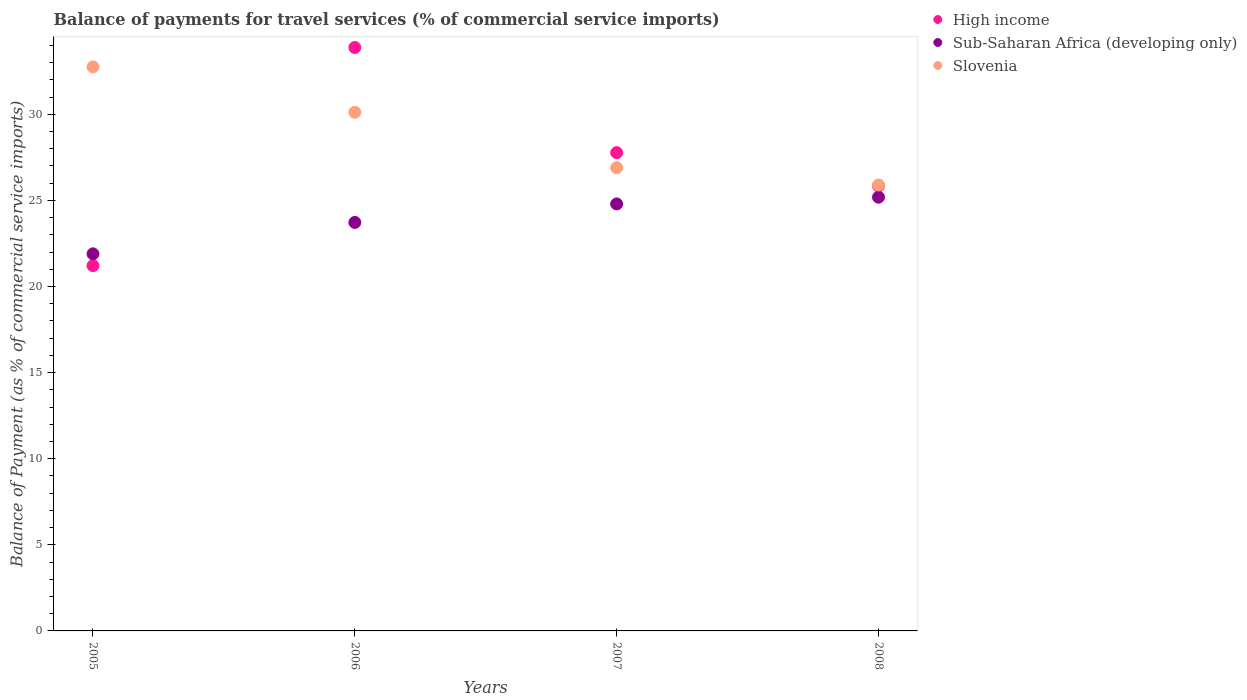How many different coloured dotlines are there?
Offer a very short reply. 3. Is the number of dotlines equal to the number of legend labels?
Make the answer very short. Yes. What is the balance of payments for travel services in Sub-Saharan Africa (developing only) in 2007?
Your response must be concise. 24.79. Across all years, what is the maximum balance of payments for travel services in Slovenia?
Offer a very short reply. 32.75. Across all years, what is the minimum balance of payments for travel services in High income?
Your response must be concise. 21.21. In which year was the balance of payments for travel services in High income maximum?
Give a very brief answer. 2006. In which year was the balance of payments for travel services in High income minimum?
Offer a terse response. 2005. What is the total balance of payments for travel services in High income in the graph?
Offer a very short reply. 108.69. What is the difference between the balance of payments for travel services in Slovenia in 2007 and that in 2008?
Give a very brief answer. 1. What is the difference between the balance of payments for travel services in High income in 2005 and the balance of payments for travel services in Slovenia in 2008?
Ensure brevity in your answer.  -4.68. What is the average balance of payments for travel services in High income per year?
Ensure brevity in your answer.  27.17. In the year 2005, what is the difference between the balance of payments for travel services in Sub-Saharan Africa (developing only) and balance of payments for travel services in High income?
Your answer should be very brief. 0.69. In how many years, is the balance of payments for travel services in Sub-Saharan Africa (developing only) greater than 26 %?
Provide a succinct answer. 0. What is the ratio of the balance of payments for travel services in Sub-Saharan Africa (developing only) in 2007 to that in 2008?
Offer a very short reply. 0.98. Is the balance of payments for travel services in Sub-Saharan Africa (developing only) in 2005 less than that in 2008?
Provide a succinct answer. Yes. What is the difference between the highest and the second highest balance of payments for travel services in Slovenia?
Your answer should be very brief. 2.64. What is the difference between the highest and the lowest balance of payments for travel services in Slovenia?
Provide a short and direct response. 6.86. Is it the case that in every year, the sum of the balance of payments for travel services in High income and balance of payments for travel services in Sub-Saharan Africa (developing only)  is greater than the balance of payments for travel services in Slovenia?
Your response must be concise. Yes. Does the balance of payments for travel services in High income monotonically increase over the years?
Offer a very short reply. No. How many dotlines are there?
Offer a terse response. 3. How many years are there in the graph?
Offer a very short reply. 4. Does the graph contain any zero values?
Your answer should be compact. No. Where does the legend appear in the graph?
Provide a succinct answer. Top right. How many legend labels are there?
Provide a succinct answer. 3. How are the legend labels stacked?
Offer a terse response. Vertical. What is the title of the graph?
Provide a succinct answer. Balance of payments for travel services (% of commercial service imports). What is the label or title of the X-axis?
Ensure brevity in your answer.  Years. What is the label or title of the Y-axis?
Give a very brief answer. Balance of Payment (as % of commercial service imports). What is the Balance of Payment (as % of commercial service imports) in High income in 2005?
Offer a terse response. 21.21. What is the Balance of Payment (as % of commercial service imports) of Sub-Saharan Africa (developing only) in 2005?
Ensure brevity in your answer.  21.89. What is the Balance of Payment (as % of commercial service imports) in Slovenia in 2005?
Keep it short and to the point. 32.75. What is the Balance of Payment (as % of commercial service imports) of High income in 2006?
Give a very brief answer. 33.88. What is the Balance of Payment (as % of commercial service imports) in Sub-Saharan Africa (developing only) in 2006?
Provide a succinct answer. 23.72. What is the Balance of Payment (as % of commercial service imports) in Slovenia in 2006?
Your answer should be compact. 30.11. What is the Balance of Payment (as % of commercial service imports) of High income in 2007?
Offer a very short reply. 27.77. What is the Balance of Payment (as % of commercial service imports) of Sub-Saharan Africa (developing only) in 2007?
Give a very brief answer. 24.79. What is the Balance of Payment (as % of commercial service imports) of Slovenia in 2007?
Your answer should be very brief. 26.9. What is the Balance of Payment (as % of commercial service imports) in High income in 2008?
Your answer should be compact. 25.84. What is the Balance of Payment (as % of commercial service imports) of Sub-Saharan Africa (developing only) in 2008?
Keep it short and to the point. 25.18. What is the Balance of Payment (as % of commercial service imports) in Slovenia in 2008?
Your answer should be very brief. 25.89. Across all years, what is the maximum Balance of Payment (as % of commercial service imports) of High income?
Your response must be concise. 33.88. Across all years, what is the maximum Balance of Payment (as % of commercial service imports) in Sub-Saharan Africa (developing only)?
Offer a terse response. 25.18. Across all years, what is the maximum Balance of Payment (as % of commercial service imports) of Slovenia?
Ensure brevity in your answer.  32.75. Across all years, what is the minimum Balance of Payment (as % of commercial service imports) of High income?
Provide a short and direct response. 21.21. Across all years, what is the minimum Balance of Payment (as % of commercial service imports) in Sub-Saharan Africa (developing only)?
Ensure brevity in your answer.  21.89. Across all years, what is the minimum Balance of Payment (as % of commercial service imports) of Slovenia?
Offer a terse response. 25.89. What is the total Balance of Payment (as % of commercial service imports) in High income in the graph?
Your answer should be compact. 108.69. What is the total Balance of Payment (as % of commercial service imports) in Sub-Saharan Africa (developing only) in the graph?
Offer a very short reply. 95.59. What is the total Balance of Payment (as % of commercial service imports) in Slovenia in the graph?
Ensure brevity in your answer.  115.65. What is the difference between the Balance of Payment (as % of commercial service imports) in High income in 2005 and that in 2006?
Offer a very short reply. -12.67. What is the difference between the Balance of Payment (as % of commercial service imports) in Sub-Saharan Africa (developing only) in 2005 and that in 2006?
Offer a terse response. -1.82. What is the difference between the Balance of Payment (as % of commercial service imports) in Slovenia in 2005 and that in 2006?
Offer a terse response. 2.64. What is the difference between the Balance of Payment (as % of commercial service imports) in High income in 2005 and that in 2007?
Make the answer very short. -6.56. What is the difference between the Balance of Payment (as % of commercial service imports) in Sub-Saharan Africa (developing only) in 2005 and that in 2007?
Your answer should be compact. -2.9. What is the difference between the Balance of Payment (as % of commercial service imports) in Slovenia in 2005 and that in 2007?
Ensure brevity in your answer.  5.86. What is the difference between the Balance of Payment (as % of commercial service imports) in High income in 2005 and that in 2008?
Your answer should be very brief. -4.63. What is the difference between the Balance of Payment (as % of commercial service imports) in Sub-Saharan Africa (developing only) in 2005 and that in 2008?
Offer a terse response. -3.29. What is the difference between the Balance of Payment (as % of commercial service imports) of Slovenia in 2005 and that in 2008?
Offer a very short reply. 6.86. What is the difference between the Balance of Payment (as % of commercial service imports) of High income in 2006 and that in 2007?
Ensure brevity in your answer.  6.11. What is the difference between the Balance of Payment (as % of commercial service imports) in Sub-Saharan Africa (developing only) in 2006 and that in 2007?
Offer a very short reply. -1.07. What is the difference between the Balance of Payment (as % of commercial service imports) of Slovenia in 2006 and that in 2007?
Offer a terse response. 3.22. What is the difference between the Balance of Payment (as % of commercial service imports) of High income in 2006 and that in 2008?
Provide a succinct answer. 8.04. What is the difference between the Balance of Payment (as % of commercial service imports) in Sub-Saharan Africa (developing only) in 2006 and that in 2008?
Give a very brief answer. -1.46. What is the difference between the Balance of Payment (as % of commercial service imports) in Slovenia in 2006 and that in 2008?
Your answer should be very brief. 4.22. What is the difference between the Balance of Payment (as % of commercial service imports) in High income in 2007 and that in 2008?
Your response must be concise. 1.93. What is the difference between the Balance of Payment (as % of commercial service imports) in Sub-Saharan Africa (developing only) in 2007 and that in 2008?
Your answer should be compact. -0.39. What is the difference between the Balance of Payment (as % of commercial service imports) in High income in 2005 and the Balance of Payment (as % of commercial service imports) in Sub-Saharan Africa (developing only) in 2006?
Offer a terse response. -2.51. What is the difference between the Balance of Payment (as % of commercial service imports) of High income in 2005 and the Balance of Payment (as % of commercial service imports) of Slovenia in 2006?
Offer a very short reply. -8.91. What is the difference between the Balance of Payment (as % of commercial service imports) of Sub-Saharan Africa (developing only) in 2005 and the Balance of Payment (as % of commercial service imports) of Slovenia in 2006?
Offer a very short reply. -8.22. What is the difference between the Balance of Payment (as % of commercial service imports) in High income in 2005 and the Balance of Payment (as % of commercial service imports) in Sub-Saharan Africa (developing only) in 2007?
Offer a terse response. -3.58. What is the difference between the Balance of Payment (as % of commercial service imports) of High income in 2005 and the Balance of Payment (as % of commercial service imports) of Slovenia in 2007?
Keep it short and to the point. -5.69. What is the difference between the Balance of Payment (as % of commercial service imports) of Sub-Saharan Africa (developing only) in 2005 and the Balance of Payment (as % of commercial service imports) of Slovenia in 2007?
Your answer should be very brief. -5. What is the difference between the Balance of Payment (as % of commercial service imports) in High income in 2005 and the Balance of Payment (as % of commercial service imports) in Sub-Saharan Africa (developing only) in 2008?
Keep it short and to the point. -3.97. What is the difference between the Balance of Payment (as % of commercial service imports) in High income in 2005 and the Balance of Payment (as % of commercial service imports) in Slovenia in 2008?
Give a very brief answer. -4.68. What is the difference between the Balance of Payment (as % of commercial service imports) of Sub-Saharan Africa (developing only) in 2005 and the Balance of Payment (as % of commercial service imports) of Slovenia in 2008?
Provide a succinct answer. -4. What is the difference between the Balance of Payment (as % of commercial service imports) of High income in 2006 and the Balance of Payment (as % of commercial service imports) of Sub-Saharan Africa (developing only) in 2007?
Your answer should be compact. 9.08. What is the difference between the Balance of Payment (as % of commercial service imports) in High income in 2006 and the Balance of Payment (as % of commercial service imports) in Slovenia in 2007?
Keep it short and to the point. 6.98. What is the difference between the Balance of Payment (as % of commercial service imports) in Sub-Saharan Africa (developing only) in 2006 and the Balance of Payment (as % of commercial service imports) in Slovenia in 2007?
Your answer should be compact. -3.18. What is the difference between the Balance of Payment (as % of commercial service imports) of High income in 2006 and the Balance of Payment (as % of commercial service imports) of Sub-Saharan Africa (developing only) in 2008?
Offer a terse response. 8.69. What is the difference between the Balance of Payment (as % of commercial service imports) in High income in 2006 and the Balance of Payment (as % of commercial service imports) in Slovenia in 2008?
Your response must be concise. 7.98. What is the difference between the Balance of Payment (as % of commercial service imports) of Sub-Saharan Africa (developing only) in 2006 and the Balance of Payment (as % of commercial service imports) of Slovenia in 2008?
Your response must be concise. -2.17. What is the difference between the Balance of Payment (as % of commercial service imports) of High income in 2007 and the Balance of Payment (as % of commercial service imports) of Sub-Saharan Africa (developing only) in 2008?
Your answer should be compact. 2.59. What is the difference between the Balance of Payment (as % of commercial service imports) of High income in 2007 and the Balance of Payment (as % of commercial service imports) of Slovenia in 2008?
Provide a short and direct response. 1.88. What is the difference between the Balance of Payment (as % of commercial service imports) in Sub-Saharan Africa (developing only) in 2007 and the Balance of Payment (as % of commercial service imports) in Slovenia in 2008?
Offer a very short reply. -1.1. What is the average Balance of Payment (as % of commercial service imports) in High income per year?
Your response must be concise. 27.17. What is the average Balance of Payment (as % of commercial service imports) in Sub-Saharan Africa (developing only) per year?
Give a very brief answer. 23.9. What is the average Balance of Payment (as % of commercial service imports) of Slovenia per year?
Your answer should be very brief. 28.91. In the year 2005, what is the difference between the Balance of Payment (as % of commercial service imports) in High income and Balance of Payment (as % of commercial service imports) in Sub-Saharan Africa (developing only)?
Give a very brief answer. -0.69. In the year 2005, what is the difference between the Balance of Payment (as % of commercial service imports) of High income and Balance of Payment (as % of commercial service imports) of Slovenia?
Give a very brief answer. -11.54. In the year 2005, what is the difference between the Balance of Payment (as % of commercial service imports) of Sub-Saharan Africa (developing only) and Balance of Payment (as % of commercial service imports) of Slovenia?
Offer a very short reply. -10.86. In the year 2006, what is the difference between the Balance of Payment (as % of commercial service imports) in High income and Balance of Payment (as % of commercial service imports) in Sub-Saharan Africa (developing only)?
Offer a terse response. 10.16. In the year 2006, what is the difference between the Balance of Payment (as % of commercial service imports) of High income and Balance of Payment (as % of commercial service imports) of Slovenia?
Give a very brief answer. 3.76. In the year 2006, what is the difference between the Balance of Payment (as % of commercial service imports) in Sub-Saharan Africa (developing only) and Balance of Payment (as % of commercial service imports) in Slovenia?
Keep it short and to the point. -6.4. In the year 2007, what is the difference between the Balance of Payment (as % of commercial service imports) of High income and Balance of Payment (as % of commercial service imports) of Sub-Saharan Africa (developing only)?
Give a very brief answer. 2.98. In the year 2007, what is the difference between the Balance of Payment (as % of commercial service imports) of High income and Balance of Payment (as % of commercial service imports) of Slovenia?
Your answer should be compact. 0.87. In the year 2007, what is the difference between the Balance of Payment (as % of commercial service imports) in Sub-Saharan Africa (developing only) and Balance of Payment (as % of commercial service imports) in Slovenia?
Make the answer very short. -2.1. In the year 2008, what is the difference between the Balance of Payment (as % of commercial service imports) of High income and Balance of Payment (as % of commercial service imports) of Sub-Saharan Africa (developing only)?
Offer a terse response. 0.65. In the year 2008, what is the difference between the Balance of Payment (as % of commercial service imports) of High income and Balance of Payment (as % of commercial service imports) of Slovenia?
Make the answer very short. -0.06. In the year 2008, what is the difference between the Balance of Payment (as % of commercial service imports) in Sub-Saharan Africa (developing only) and Balance of Payment (as % of commercial service imports) in Slovenia?
Offer a terse response. -0.71. What is the ratio of the Balance of Payment (as % of commercial service imports) in High income in 2005 to that in 2006?
Provide a short and direct response. 0.63. What is the ratio of the Balance of Payment (as % of commercial service imports) of Sub-Saharan Africa (developing only) in 2005 to that in 2006?
Keep it short and to the point. 0.92. What is the ratio of the Balance of Payment (as % of commercial service imports) in Slovenia in 2005 to that in 2006?
Give a very brief answer. 1.09. What is the ratio of the Balance of Payment (as % of commercial service imports) of High income in 2005 to that in 2007?
Offer a very short reply. 0.76. What is the ratio of the Balance of Payment (as % of commercial service imports) of Sub-Saharan Africa (developing only) in 2005 to that in 2007?
Give a very brief answer. 0.88. What is the ratio of the Balance of Payment (as % of commercial service imports) in Slovenia in 2005 to that in 2007?
Offer a terse response. 1.22. What is the ratio of the Balance of Payment (as % of commercial service imports) of High income in 2005 to that in 2008?
Your answer should be very brief. 0.82. What is the ratio of the Balance of Payment (as % of commercial service imports) of Sub-Saharan Africa (developing only) in 2005 to that in 2008?
Provide a short and direct response. 0.87. What is the ratio of the Balance of Payment (as % of commercial service imports) of Slovenia in 2005 to that in 2008?
Offer a terse response. 1.26. What is the ratio of the Balance of Payment (as % of commercial service imports) of High income in 2006 to that in 2007?
Offer a very short reply. 1.22. What is the ratio of the Balance of Payment (as % of commercial service imports) of Sub-Saharan Africa (developing only) in 2006 to that in 2007?
Ensure brevity in your answer.  0.96. What is the ratio of the Balance of Payment (as % of commercial service imports) in Slovenia in 2006 to that in 2007?
Keep it short and to the point. 1.12. What is the ratio of the Balance of Payment (as % of commercial service imports) in High income in 2006 to that in 2008?
Provide a short and direct response. 1.31. What is the ratio of the Balance of Payment (as % of commercial service imports) of Sub-Saharan Africa (developing only) in 2006 to that in 2008?
Your answer should be very brief. 0.94. What is the ratio of the Balance of Payment (as % of commercial service imports) in Slovenia in 2006 to that in 2008?
Give a very brief answer. 1.16. What is the ratio of the Balance of Payment (as % of commercial service imports) of High income in 2007 to that in 2008?
Ensure brevity in your answer.  1.07. What is the ratio of the Balance of Payment (as % of commercial service imports) in Sub-Saharan Africa (developing only) in 2007 to that in 2008?
Provide a short and direct response. 0.98. What is the ratio of the Balance of Payment (as % of commercial service imports) of Slovenia in 2007 to that in 2008?
Ensure brevity in your answer.  1.04. What is the difference between the highest and the second highest Balance of Payment (as % of commercial service imports) in High income?
Make the answer very short. 6.11. What is the difference between the highest and the second highest Balance of Payment (as % of commercial service imports) in Sub-Saharan Africa (developing only)?
Offer a very short reply. 0.39. What is the difference between the highest and the second highest Balance of Payment (as % of commercial service imports) of Slovenia?
Your answer should be compact. 2.64. What is the difference between the highest and the lowest Balance of Payment (as % of commercial service imports) in High income?
Keep it short and to the point. 12.67. What is the difference between the highest and the lowest Balance of Payment (as % of commercial service imports) in Sub-Saharan Africa (developing only)?
Your answer should be very brief. 3.29. What is the difference between the highest and the lowest Balance of Payment (as % of commercial service imports) in Slovenia?
Provide a short and direct response. 6.86. 